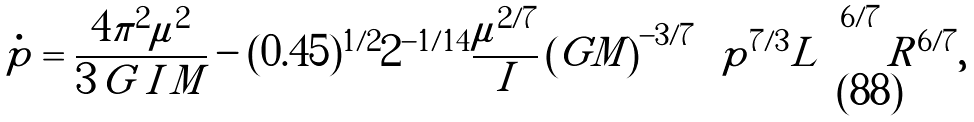Convert formula to latex. <formula><loc_0><loc_0><loc_500><loc_500>\dot { p } = \frac { 4 \pi ^ { 2 } \mu ^ { 2 } } { 3 \, G \, I \, M } - ( 0 . 4 5 ) ^ { 1 / 2 } 2 ^ { - 1 / 1 4 } \frac { \mu ^ { 2 / 7 } } { I } \left ( G M \right ) ^ { - 3 / 7 } \left [ p ^ { 7 / 3 } L \right ] ^ { 6 / 7 } R ^ { 6 / 7 } ,</formula> 